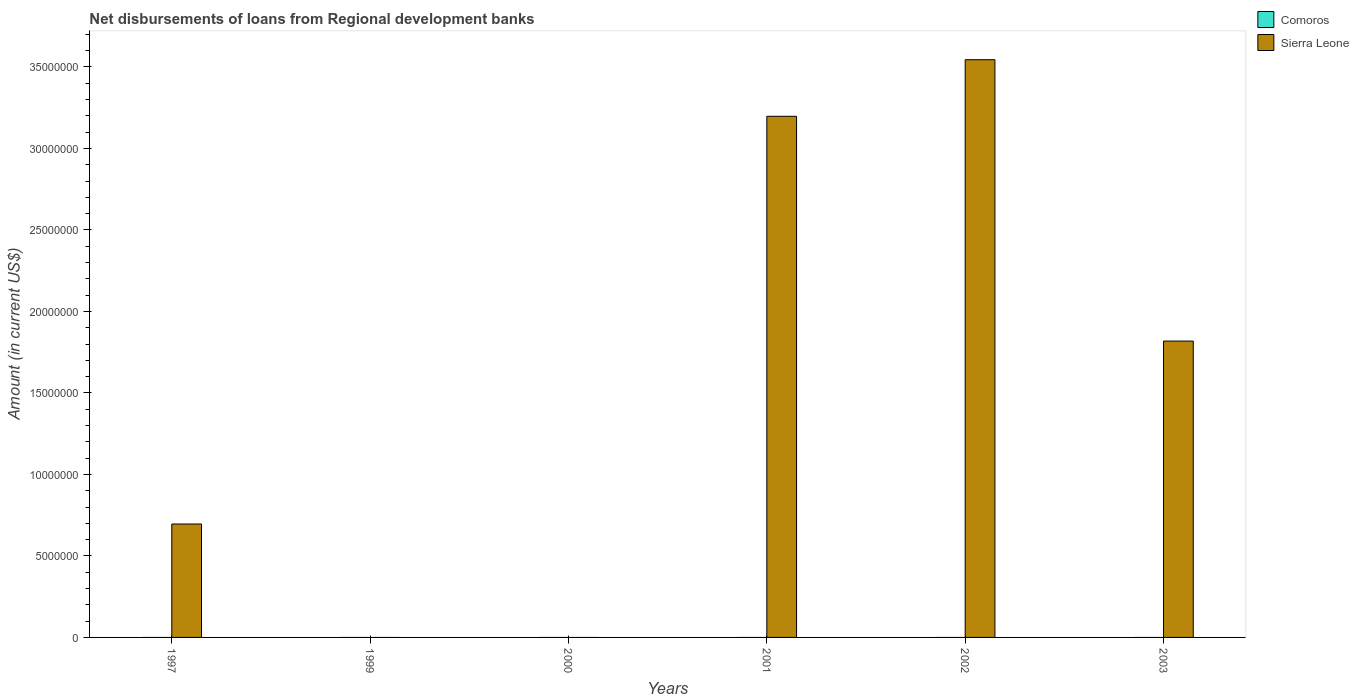In how many cases, is the number of bars for a given year not equal to the number of legend labels?
Make the answer very short. 6. What is the amount of disbursements of loans from regional development banks in Sierra Leone in 2002?
Provide a succinct answer. 3.54e+07. Across all years, what is the maximum amount of disbursements of loans from regional development banks in Sierra Leone?
Your answer should be very brief. 3.54e+07. What is the total amount of disbursements of loans from regional development banks in Sierra Leone in the graph?
Offer a terse response. 9.26e+07. What is the difference between the amount of disbursements of loans from regional development banks in Sierra Leone in 2001 and that in 2002?
Your answer should be compact. -3.47e+06. What is the difference between the amount of disbursements of loans from regional development banks in Sierra Leone in 2001 and the amount of disbursements of loans from regional development banks in Comoros in 1999?
Provide a short and direct response. 3.20e+07. What is the average amount of disbursements of loans from regional development banks in Comoros per year?
Offer a very short reply. 0. What is the ratio of the amount of disbursements of loans from regional development banks in Sierra Leone in 2001 to that in 2002?
Offer a terse response. 0.9. What is the difference between the highest and the second highest amount of disbursements of loans from regional development banks in Sierra Leone?
Give a very brief answer. 3.47e+06. What is the difference between the highest and the lowest amount of disbursements of loans from regional development banks in Sierra Leone?
Provide a succinct answer. 3.54e+07. In how many years, is the amount of disbursements of loans from regional development banks in Sierra Leone greater than the average amount of disbursements of loans from regional development banks in Sierra Leone taken over all years?
Ensure brevity in your answer.  3. Is the sum of the amount of disbursements of loans from regional development banks in Sierra Leone in 2002 and 2003 greater than the maximum amount of disbursements of loans from regional development banks in Comoros across all years?
Your answer should be very brief. Yes. How many bars are there?
Your response must be concise. 4. Are all the bars in the graph horizontal?
Provide a succinct answer. No. How many years are there in the graph?
Your answer should be very brief. 6. Are the values on the major ticks of Y-axis written in scientific E-notation?
Your answer should be compact. No. Where does the legend appear in the graph?
Provide a short and direct response. Top right. How many legend labels are there?
Provide a succinct answer. 2. How are the legend labels stacked?
Your answer should be very brief. Vertical. What is the title of the graph?
Keep it short and to the point. Net disbursements of loans from Regional development banks. What is the label or title of the Y-axis?
Your answer should be very brief. Amount (in current US$). What is the Amount (in current US$) in Comoros in 1997?
Your response must be concise. 0. What is the Amount (in current US$) in Sierra Leone in 1997?
Your answer should be compact. 6.96e+06. What is the Amount (in current US$) in Comoros in 1999?
Ensure brevity in your answer.  0. What is the Amount (in current US$) of Sierra Leone in 1999?
Ensure brevity in your answer.  0. What is the Amount (in current US$) of Comoros in 2001?
Ensure brevity in your answer.  0. What is the Amount (in current US$) of Sierra Leone in 2001?
Your answer should be very brief. 3.20e+07. What is the Amount (in current US$) in Comoros in 2002?
Your response must be concise. 0. What is the Amount (in current US$) in Sierra Leone in 2002?
Provide a succinct answer. 3.54e+07. What is the Amount (in current US$) of Sierra Leone in 2003?
Your answer should be very brief. 1.82e+07. Across all years, what is the maximum Amount (in current US$) in Sierra Leone?
Your answer should be very brief. 3.54e+07. What is the total Amount (in current US$) of Comoros in the graph?
Provide a succinct answer. 0. What is the total Amount (in current US$) of Sierra Leone in the graph?
Your answer should be compact. 9.26e+07. What is the difference between the Amount (in current US$) in Sierra Leone in 1997 and that in 2001?
Ensure brevity in your answer.  -2.50e+07. What is the difference between the Amount (in current US$) in Sierra Leone in 1997 and that in 2002?
Offer a very short reply. -2.85e+07. What is the difference between the Amount (in current US$) in Sierra Leone in 1997 and that in 2003?
Your answer should be very brief. -1.12e+07. What is the difference between the Amount (in current US$) of Sierra Leone in 2001 and that in 2002?
Provide a succinct answer. -3.47e+06. What is the difference between the Amount (in current US$) in Sierra Leone in 2001 and that in 2003?
Keep it short and to the point. 1.38e+07. What is the difference between the Amount (in current US$) in Sierra Leone in 2002 and that in 2003?
Ensure brevity in your answer.  1.73e+07. What is the average Amount (in current US$) of Comoros per year?
Keep it short and to the point. 0. What is the average Amount (in current US$) of Sierra Leone per year?
Your answer should be compact. 1.54e+07. What is the ratio of the Amount (in current US$) of Sierra Leone in 1997 to that in 2001?
Keep it short and to the point. 0.22. What is the ratio of the Amount (in current US$) in Sierra Leone in 1997 to that in 2002?
Your answer should be compact. 0.2. What is the ratio of the Amount (in current US$) of Sierra Leone in 1997 to that in 2003?
Provide a short and direct response. 0.38. What is the ratio of the Amount (in current US$) of Sierra Leone in 2001 to that in 2002?
Provide a succinct answer. 0.9. What is the ratio of the Amount (in current US$) of Sierra Leone in 2001 to that in 2003?
Make the answer very short. 1.76. What is the ratio of the Amount (in current US$) in Sierra Leone in 2002 to that in 2003?
Your response must be concise. 1.95. What is the difference between the highest and the second highest Amount (in current US$) in Sierra Leone?
Make the answer very short. 3.47e+06. What is the difference between the highest and the lowest Amount (in current US$) in Sierra Leone?
Offer a terse response. 3.54e+07. 